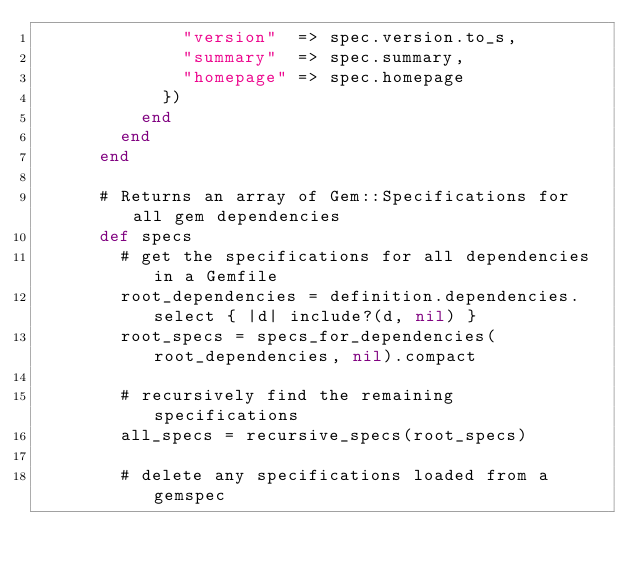Convert code to text. <code><loc_0><loc_0><loc_500><loc_500><_Ruby_>              "version"  => spec.version.to_s,
              "summary"  => spec.summary,
              "homepage" => spec.homepage
            })
          end
        end
      end

      # Returns an array of Gem::Specifications for all gem dependencies
      def specs
        # get the specifications for all dependencies in a Gemfile
        root_dependencies = definition.dependencies.select { |d| include?(d, nil) }
        root_specs = specs_for_dependencies(root_dependencies, nil).compact

        # recursively find the remaining specifications
        all_specs = recursive_specs(root_specs)

        # delete any specifications loaded from a gemspec</code> 